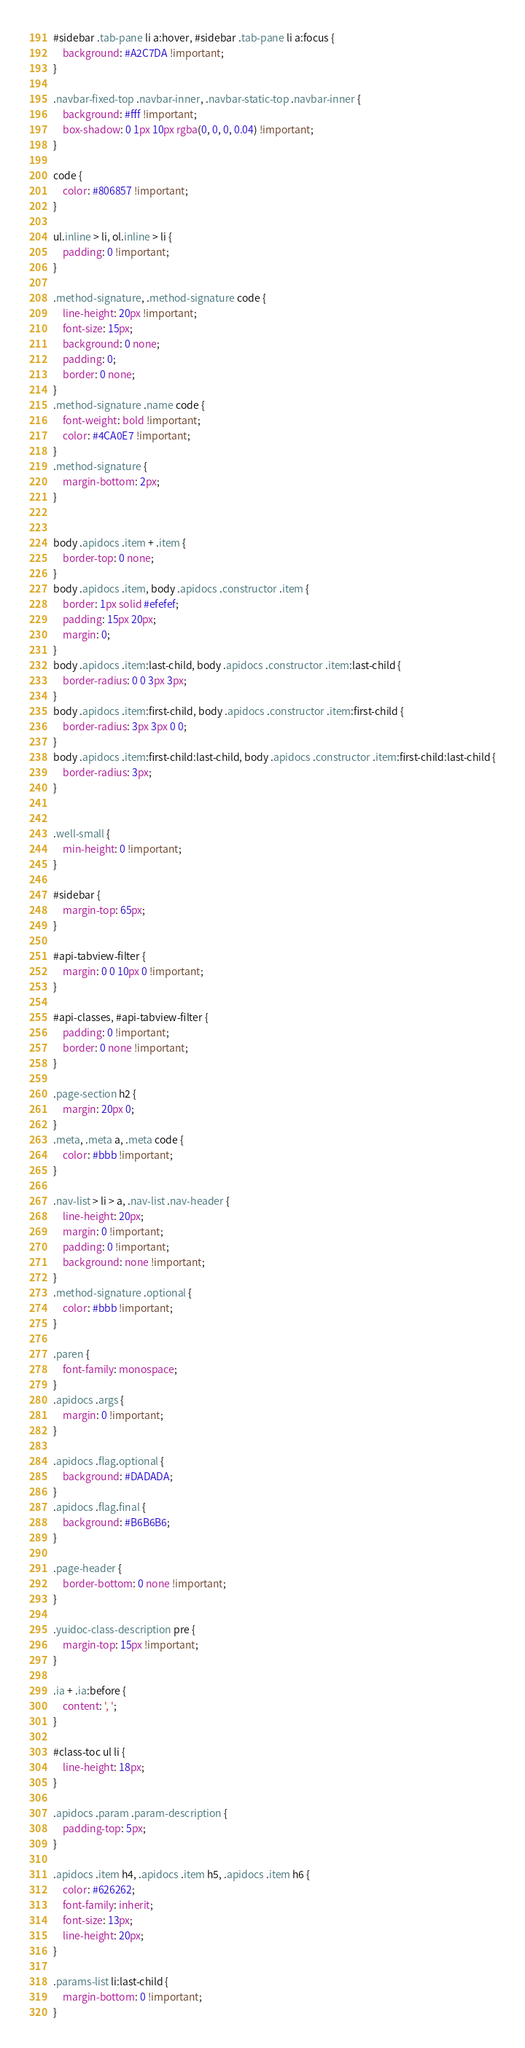<code> <loc_0><loc_0><loc_500><loc_500><_CSS_>
#sidebar .tab-pane li a:hover, #sidebar .tab-pane li a:focus {
	background: #A2C7DA !important;
}

.navbar-fixed-top .navbar-inner, .navbar-static-top .navbar-inner {
	background: #fff !important;
	box-shadow: 0 1px 10px rgba(0, 0, 0, 0.04) !important;
}

code {
	color: #806857 !important;
}

ul.inline > li, ol.inline > li {
	padding: 0 !important;
}

.method-signature, .method-signature code {
	line-height: 20px !important;
	font-size: 15px;
	background: 0 none;
	padding: 0;
	border: 0 none;
}
.method-signature .name code {
	font-weight: bold !important;
	color: #4CA0E7 !important;
}
.method-signature {
	margin-bottom: 2px;
}


body .apidocs .item + .item {
	border-top: 0 none;
}
body .apidocs .item, body .apidocs .constructor .item {
	border: 1px solid #efefef;
	padding: 15px 20px;
	margin: 0;
}
body .apidocs .item:last-child, body .apidocs .constructor .item:last-child {
	border-radius: 0 0 3px 3px;
}
body .apidocs .item:first-child, body .apidocs .constructor .item:first-child {
	border-radius: 3px 3px 0 0;
}
body .apidocs .item:first-child:last-child, body .apidocs .constructor .item:first-child:last-child {
	border-radius: 3px;
}


.well-small {
	min-height: 0 !important;
}

#sidebar {
	margin-top: 65px;
}

#api-tabview-filter {
	margin: 0 0 10px 0 !important;
}

#api-classes, #api-tabview-filter {
	padding: 0 !important;
	border: 0 none !important;
}

.page-section h2 {
	margin: 20px 0;
}
.meta, .meta a, .meta code {
	color: #bbb !important;
}

.nav-list > li > a, .nav-list .nav-header {
	line-height: 20px;
	margin: 0 !important;
	padding: 0 !important;
	background: none !important;
}
.method-signature .optional {
	color: #bbb !important;
}

.paren {
	font-family: monospace;
}
.apidocs .args {
	margin: 0 !important;
}

.apidocs .flag.optional {
	background: #DADADA;
}
.apidocs .flag.final {
	background: #B6B6B6;
}

.page-header {
	border-bottom: 0 none !important;
}

.yuidoc-class-description pre {
	margin-top: 15px !important;
}

.ia + .ia:before {
	content: ', ';
}

#class-toc ul li {
	line-height: 18px;
}

.apidocs .param .param-description {
	padding-top: 5px;
}

.apidocs .item h4, .apidocs .item h5, .apidocs .item h6 {
	color: #626262;
	font-family: inherit;
	font-size: 13px;
	line-height: 20px;
}

.params-list li:last-child {
	margin-bottom: 0 !important;
}</code> 